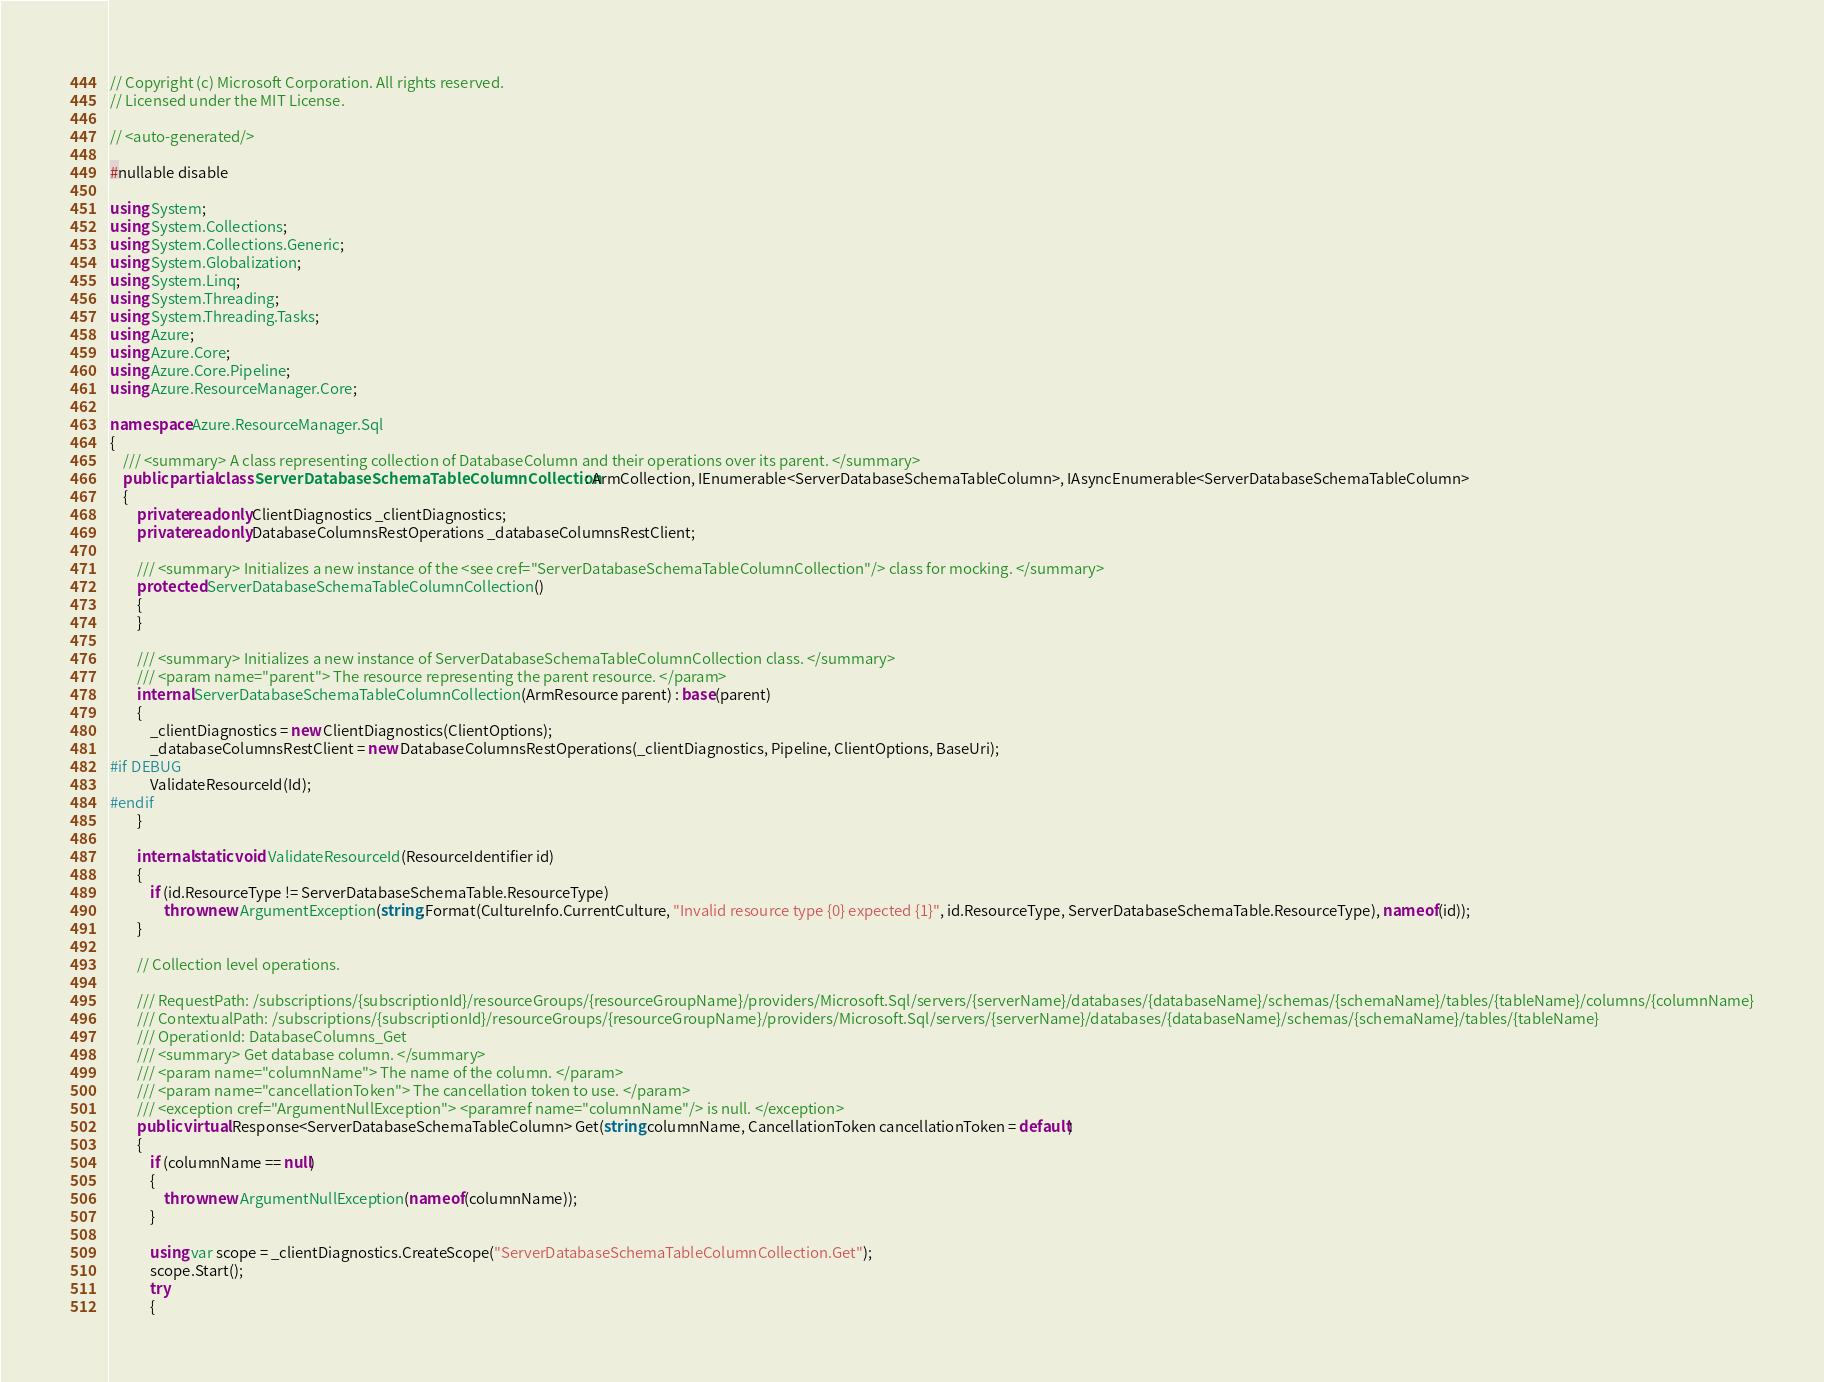<code> <loc_0><loc_0><loc_500><loc_500><_C#_>// Copyright (c) Microsoft Corporation. All rights reserved.
// Licensed under the MIT License.

// <auto-generated/>

#nullable disable

using System;
using System.Collections;
using System.Collections.Generic;
using System.Globalization;
using System.Linq;
using System.Threading;
using System.Threading.Tasks;
using Azure;
using Azure.Core;
using Azure.Core.Pipeline;
using Azure.ResourceManager.Core;

namespace Azure.ResourceManager.Sql
{
    /// <summary> A class representing collection of DatabaseColumn and their operations over its parent. </summary>
    public partial class ServerDatabaseSchemaTableColumnCollection : ArmCollection, IEnumerable<ServerDatabaseSchemaTableColumn>, IAsyncEnumerable<ServerDatabaseSchemaTableColumn>
    {
        private readonly ClientDiagnostics _clientDiagnostics;
        private readonly DatabaseColumnsRestOperations _databaseColumnsRestClient;

        /// <summary> Initializes a new instance of the <see cref="ServerDatabaseSchemaTableColumnCollection"/> class for mocking. </summary>
        protected ServerDatabaseSchemaTableColumnCollection()
        {
        }

        /// <summary> Initializes a new instance of ServerDatabaseSchemaTableColumnCollection class. </summary>
        /// <param name="parent"> The resource representing the parent resource. </param>
        internal ServerDatabaseSchemaTableColumnCollection(ArmResource parent) : base(parent)
        {
            _clientDiagnostics = new ClientDiagnostics(ClientOptions);
            _databaseColumnsRestClient = new DatabaseColumnsRestOperations(_clientDiagnostics, Pipeline, ClientOptions, BaseUri);
#if DEBUG
			ValidateResourceId(Id);
#endif
        }

        internal static void ValidateResourceId(ResourceIdentifier id)
        {
            if (id.ResourceType != ServerDatabaseSchemaTable.ResourceType)
                throw new ArgumentException(string.Format(CultureInfo.CurrentCulture, "Invalid resource type {0} expected {1}", id.ResourceType, ServerDatabaseSchemaTable.ResourceType), nameof(id));
        }

        // Collection level operations.

        /// RequestPath: /subscriptions/{subscriptionId}/resourceGroups/{resourceGroupName}/providers/Microsoft.Sql/servers/{serverName}/databases/{databaseName}/schemas/{schemaName}/tables/{tableName}/columns/{columnName}
        /// ContextualPath: /subscriptions/{subscriptionId}/resourceGroups/{resourceGroupName}/providers/Microsoft.Sql/servers/{serverName}/databases/{databaseName}/schemas/{schemaName}/tables/{tableName}
        /// OperationId: DatabaseColumns_Get
        /// <summary> Get database column. </summary>
        /// <param name="columnName"> The name of the column. </param>
        /// <param name="cancellationToken"> The cancellation token to use. </param>
        /// <exception cref="ArgumentNullException"> <paramref name="columnName"/> is null. </exception>
        public virtual Response<ServerDatabaseSchemaTableColumn> Get(string columnName, CancellationToken cancellationToken = default)
        {
            if (columnName == null)
            {
                throw new ArgumentNullException(nameof(columnName));
            }

            using var scope = _clientDiagnostics.CreateScope("ServerDatabaseSchemaTableColumnCollection.Get");
            scope.Start();
            try
            {</code> 